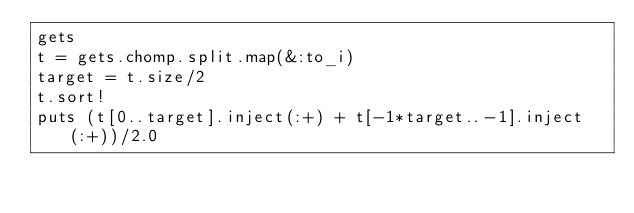<code> <loc_0><loc_0><loc_500><loc_500><_Ruby_>gets
t = gets.chomp.split.map(&:to_i)
target = t.size/2
t.sort!
puts (t[0..target].inject(:+) + t[-1*target..-1].inject(:+))/2.0</code> 